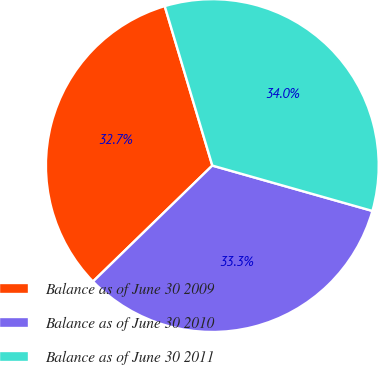Convert chart to OTSL. <chart><loc_0><loc_0><loc_500><loc_500><pie_chart><fcel>Balance as of June 30 2009<fcel>Balance as of June 30 2010<fcel>Balance as of June 30 2011<nl><fcel>32.65%<fcel>33.33%<fcel>34.01%<nl></chart> 